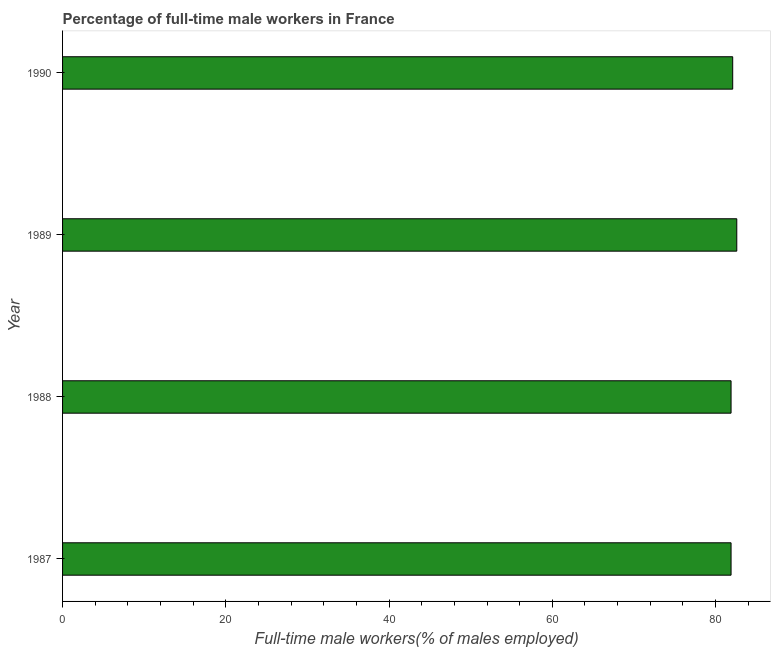Does the graph contain grids?
Offer a terse response. No. What is the title of the graph?
Provide a short and direct response. Percentage of full-time male workers in France. What is the label or title of the X-axis?
Provide a short and direct response. Full-time male workers(% of males employed). What is the label or title of the Y-axis?
Your answer should be very brief. Year. What is the percentage of full-time male workers in 1988?
Offer a terse response. 81.9. Across all years, what is the maximum percentage of full-time male workers?
Ensure brevity in your answer.  82.6. Across all years, what is the minimum percentage of full-time male workers?
Offer a terse response. 81.9. In which year was the percentage of full-time male workers maximum?
Offer a terse response. 1989. What is the sum of the percentage of full-time male workers?
Provide a short and direct response. 328.5. What is the difference between the percentage of full-time male workers in 1989 and 1990?
Provide a succinct answer. 0.5. What is the average percentage of full-time male workers per year?
Keep it short and to the point. 82.12. What is the median percentage of full-time male workers?
Make the answer very short. 82. Is the difference between the percentage of full-time male workers in 1987 and 1989 greater than the difference between any two years?
Provide a short and direct response. Yes. What is the difference between the highest and the lowest percentage of full-time male workers?
Provide a short and direct response. 0.7. In how many years, is the percentage of full-time male workers greater than the average percentage of full-time male workers taken over all years?
Keep it short and to the point. 1. Are all the bars in the graph horizontal?
Your answer should be very brief. Yes. How many years are there in the graph?
Give a very brief answer. 4. What is the Full-time male workers(% of males employed) of 1987?
Offer a very short reply. 81.9. What is the Full-time male workers(% of males employed) in 1988?
Your answer should be compact. 81.9. What is the Full-time male workers(% of males employed) of 1989?
Keep it short and to the point. 82.6. What is the Full-time male workers(% of males employed) of 1990?
Your answer should be compact. 82.1. What is the difference between the Full-time male workers(% of males employed) in 1987 and 1990?
Offer a terse response. -0.2. What is the difference between the Full-time male workers(% of males employed) in 1988 and 1989?
Offer a very short reply. -0.7. What is the difference between the Full-time male workers(% of males employed) in 1988 and 1990?
Make the answer very short. -0.2. What is the ratio of the Full-time male workers(% of males employed) in 1987 to that in 1988?
Make the answer very short. 1. What is the ratio of the Full-time male workers(% of males employed) in 1987 to that in 1990?
Offer a terse response. 1. What is the ratio of the Full-time male workers(% of males employed) in 1988 to that in 1989?
Make the answer very short. 0.99. What is the ratio of the Full-time male workers(% of males employed) in 1988 to that in 1990?
Offer a very short reply. 1. 